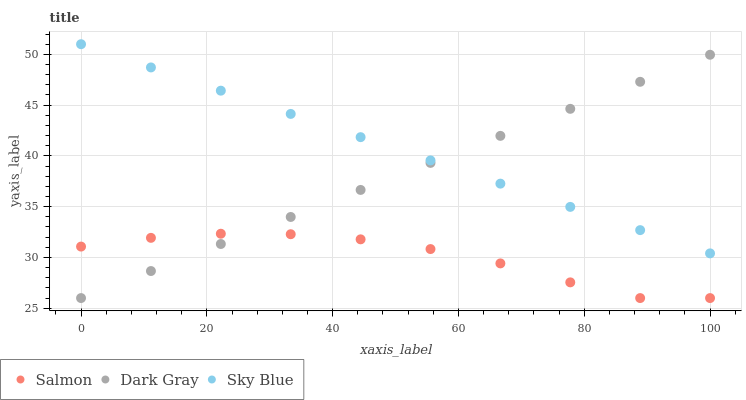Does Salmon have the minimum area under the curve?
Answer yes or no. Yes. Does Sky Blue have the maximum area under the curve?
Answer yes or no. Yes. Does Sky Blue have the minimum area under the curve?
Answer yes or no. No. Does Salmon have the maximum area under the curve?
Answer yes or no. No. Is Sky Blue the smoothest?
Answer yes or no. Yes. Is Salmon the roughest?
Answer yes or no. Yes. Is Salmon the smoothest?
Answer yes or no. No. Is Sky Blue the roughest?
Answer yes or no. No. Does Dark Gray have the lowest value?
Answer yes or no. Yes. Does Sky Blue have the lowest value?
Answer yes or no. No. Does Sky Blue have the highest value?
Answer yes or no. Yes. Does Salmon have the highest value?
Answer yes or no. No. Is Salmon less than Sky Blue?
Answer yes or no. Yes. Is Sky Blue greater than Salmon?
Answer yes or no. Yes. Does Dark Gray intersect Sky Blue?
Answer yes or no. Yes. Is Dark Gray less than Sky Blue?
Answer yes or no. No. Is Dark Gray greater than Sky Blue?
Answer yes or no. No. Does Salmon intersect Sky Blue?
Answer yes or no. No. 